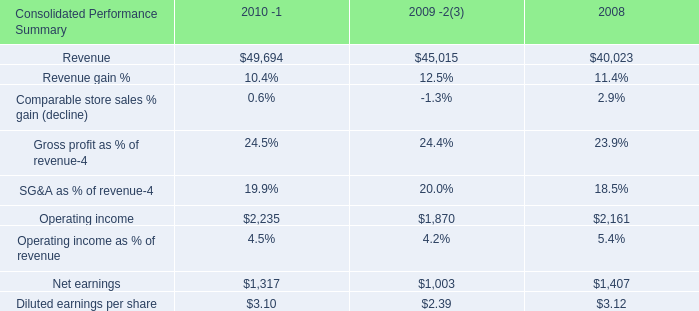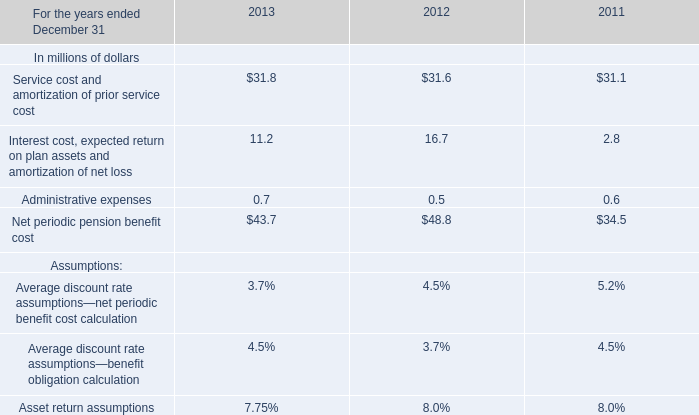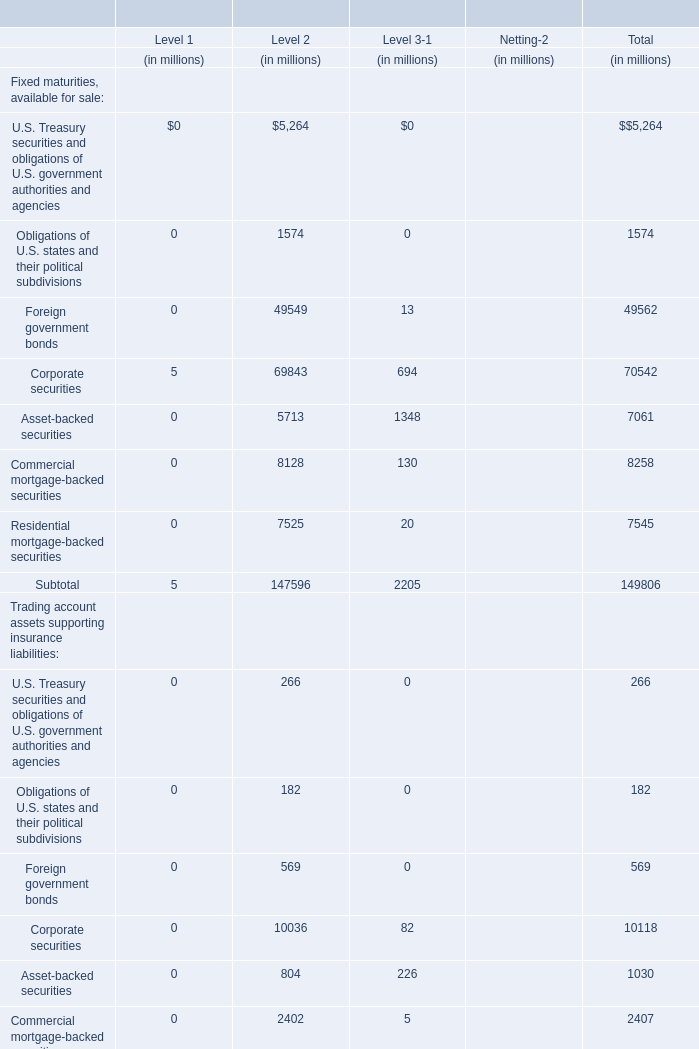Which element makes up more than 10 % of the total of Fixed maturities, available for sale in for Total in 2010? 
Answer: Foreign government bonds, Corporate securities. 